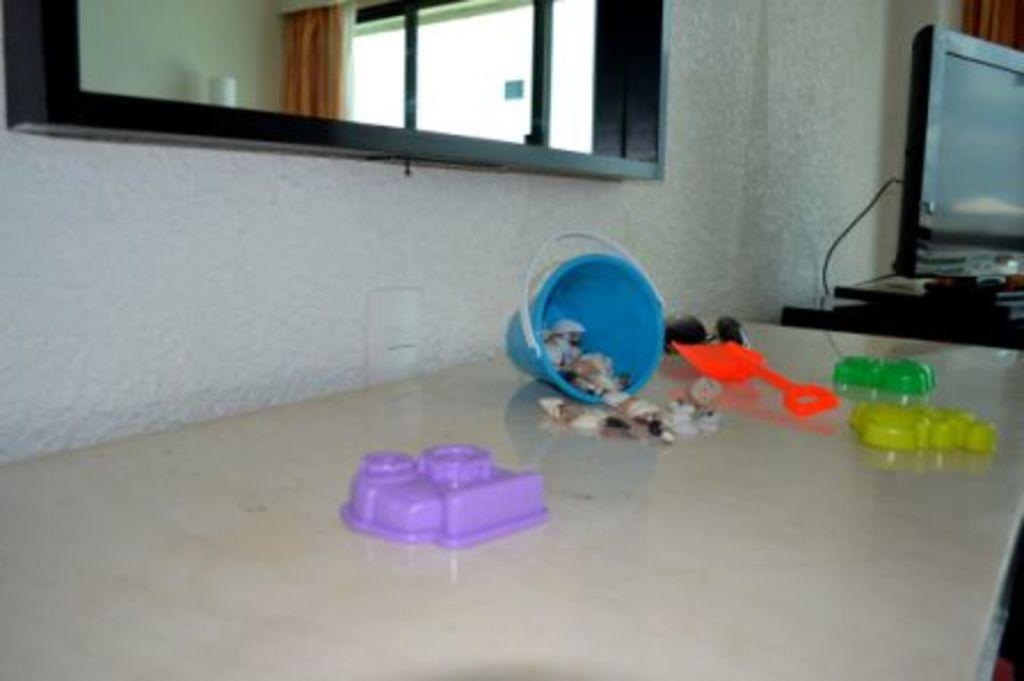Please provide a concise description of this image. In the picture we can see a table and some toys on placed on table, beside the table we can see a television. In the background we can see a wall, window and a curtain. 